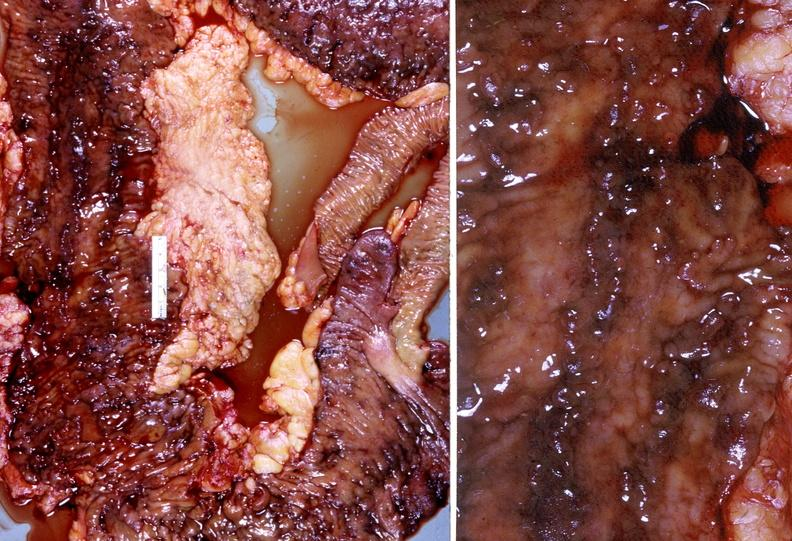does this partially fixed gross show colon, chronic ulcerative colitis?
Answer the question using a single word or phrase. No 